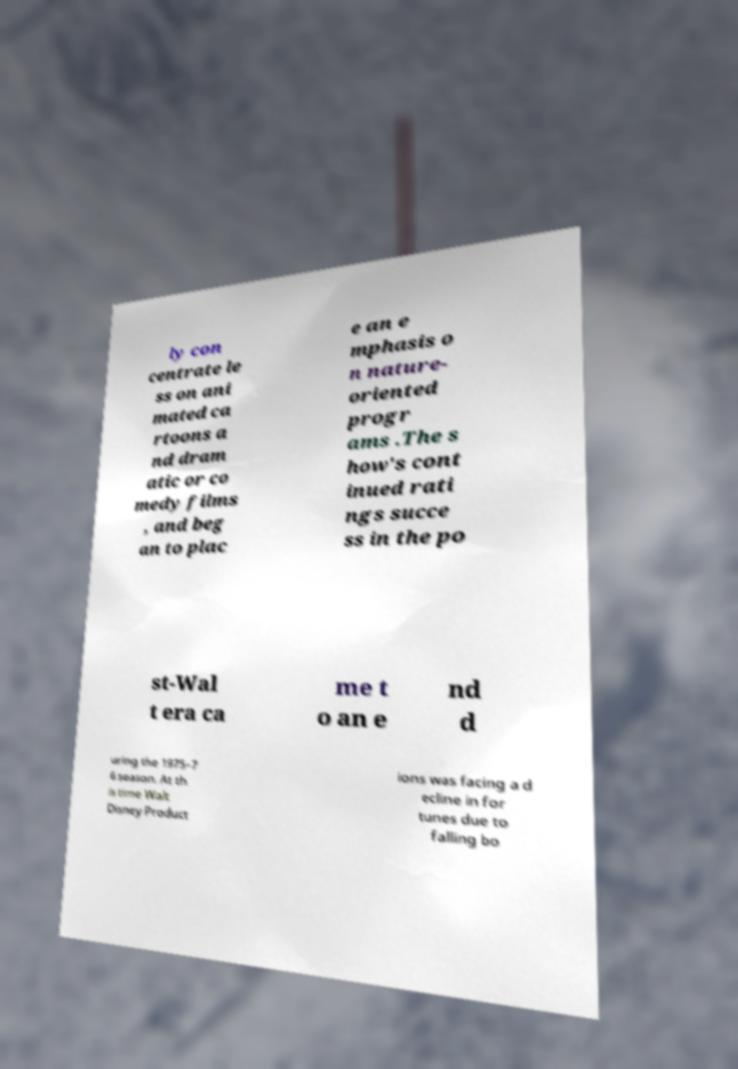What messages or text are displayed in this image? I need them in a readable, typed format. ly con centrate le ss on ani mated ca rtoons a nd dram atic or co medy films , and beg an to plac e an e mphasis o n nature- oriented progr ams .The s how's cont inued rati ngs succe ss in the po st-Wal t era ca me t o an e nd d uring the 1975–7 6 season. At th is time Walt Disney Product ions was facing a d ecline in for tunes due to falling bo 